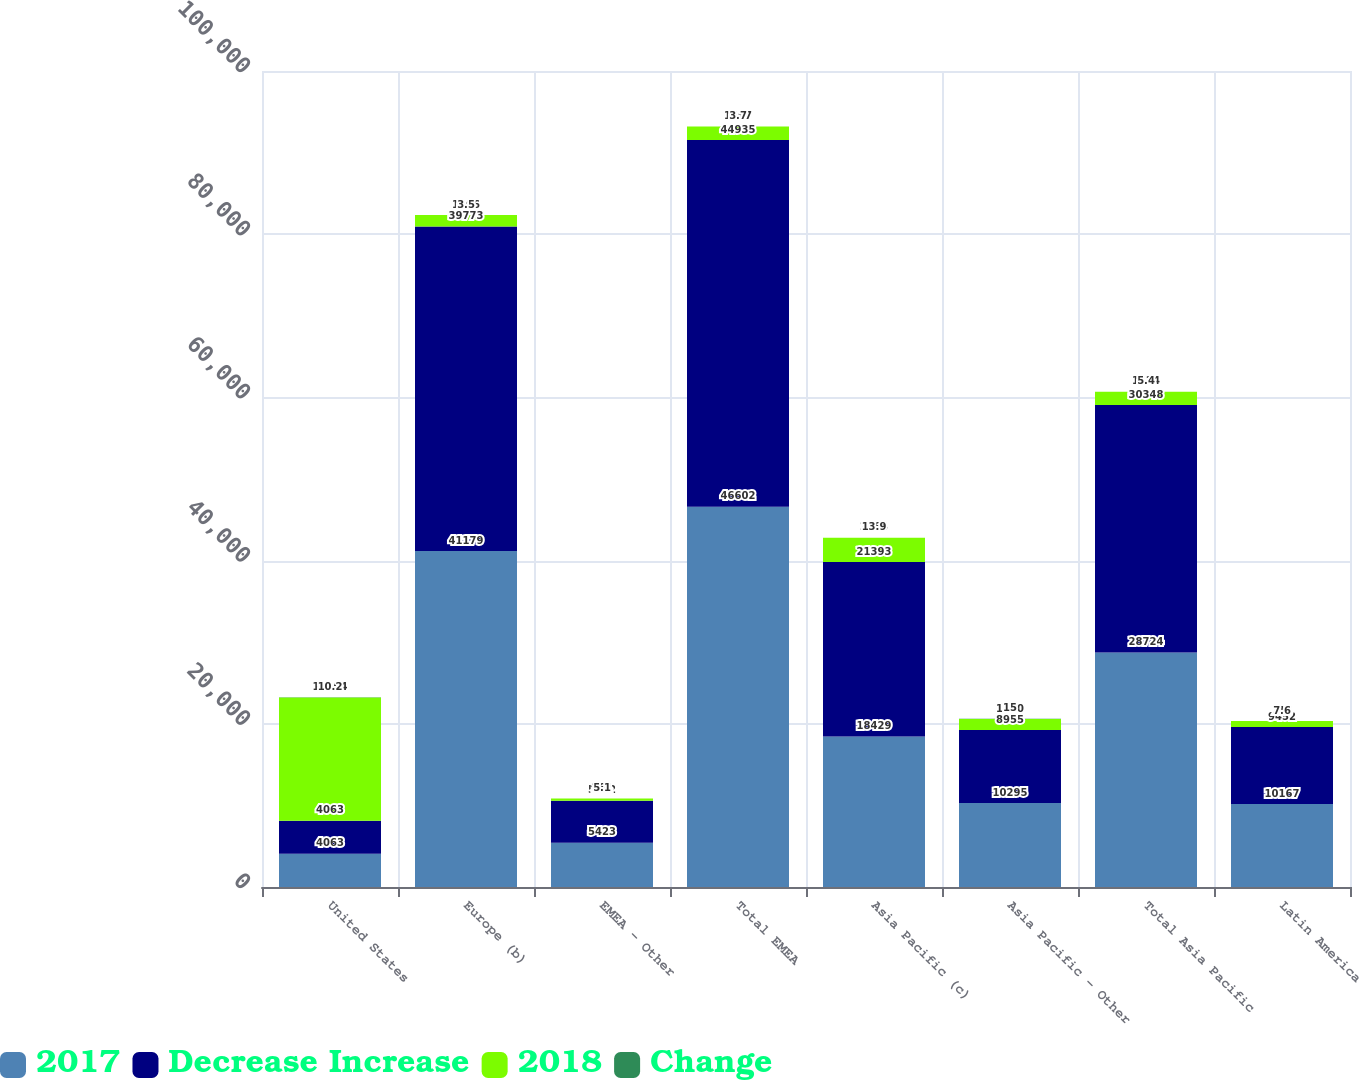Convert chart. <chart><loc_0><loc_0><loc_500><loc_500><stacked_bar_chart><ecel><fcel>United States<fcel>Europe (b)<fcel>EMEA - Other<fcel>Total EMEA<fcel>Asia Pacific (c)<fcel>Asia Pacific - Other<fcel>Total Asia Pacific<fcel>Latin America<nl><fcel>2017<fcel>4063<fcel>41179<fcel>5423<fcel>46602<fcel>18429<fcel>10295<fcel>28724<fcel>10167<nl><fcel>Decrease Increase<fcel>4063<fcel>39773<fcel>5162<fcel>44935<fcel>21393<fcel>8955<fcel>30348<fcel>9452<nl><fcel>2018<fcel>15104<fcel>1406<fcel>261<fcel>1667<fcel>2964<fcel>1340<fcel>1624<fcel>715<nl><fcel>Change<fcel>10.2<fcel>3.5<fcel>5.1<fcel>3.7<fcel>13.9<fcel>15<fcel>5.4<fcel>7.6<nl></chart> 